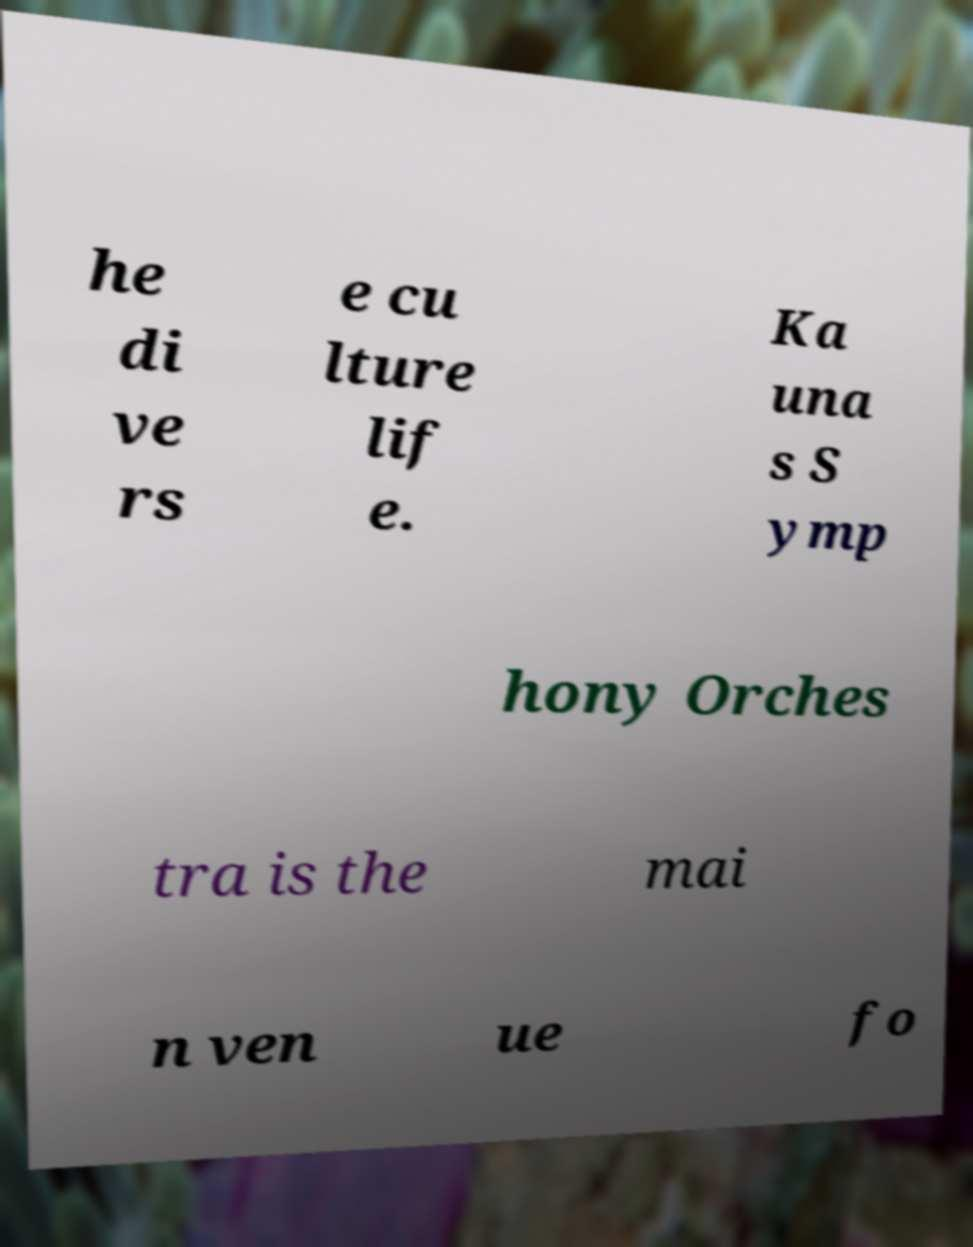Please read and relay the text visible in this image. What does it say? he di ve rs e cu lture lif e. Ka una s S ymp hony Orches tra is the mai n ven ue fo 